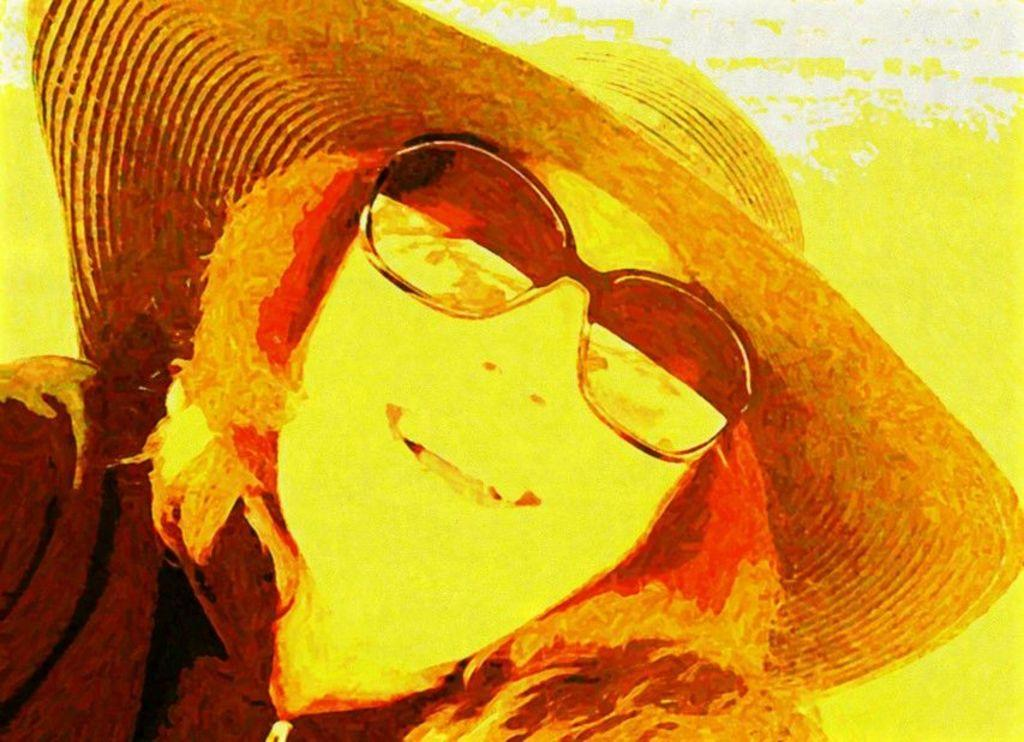What is the main subject of the painting in the image? The painting depicts a woman. What accessories is the woman wearing in the painting? The woman is wearing a hat and goggles in the painting. What color is the jacket the woman is wearing in the painting? The woman is wearing a black color jacket in the painting. Can you see any cherries on the bridge in the image? There is no bridge or cherries present in the image; it features a painting of a woman wearing a hat, goggles, and a black jacket. 